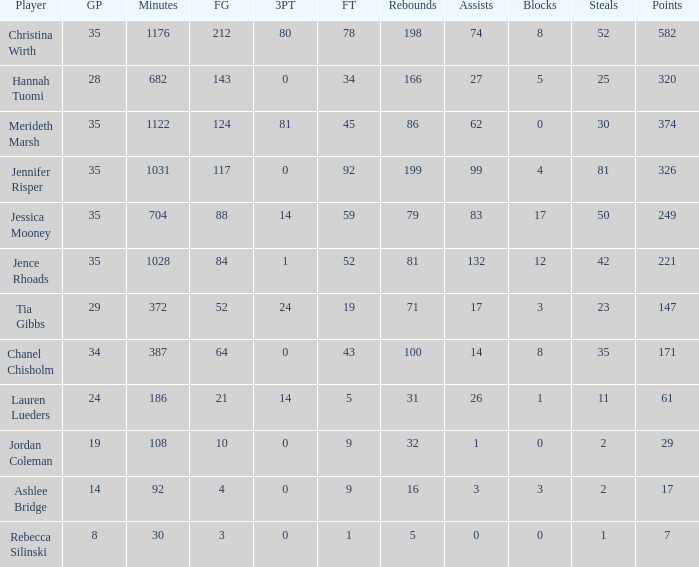What is the minimum number of games played by the player with 50 thefts? 35.0. 